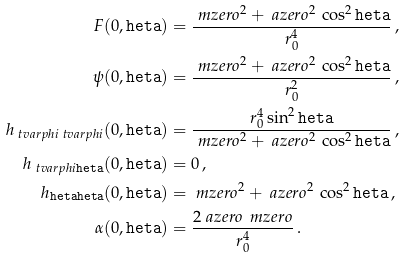<formula> <loc_0><loc_0><loc_500><loc_500>F ( 0 , \tt h e t a ) & = \frac { \ m z e r o ^ { 2 } + \ a z e r o ^ { 2 } \, \cos ^ { 2 } \tt h e t a } { r _ { 0 } ^ { 4 } } \, , \\ \psi ( 0 , \tt h e t a ) & = \frac { \ m z e r o ^ { 2 } + \ a z e r o ^ { 2 } \, \cos ^ { 2 } \tt h e t a } { r _ { 0 } ^ { 2 } } \, , \\ h _ { \ t v a r p h i \ t v a r p h i } ( 0 , \tt h e t a ) & = \frac { r _ { 0 } ^ { 4 } \sin ^ { 2 } \tt h e t a } { \ m z e r o ^ { 2 } + \ a z e r o ^ { 2 } \, \cos ^ { 2 } \tt h e t a } \, , \\ h _ { \ t v a r p h i \tt h e t a } ( 0 , \tt h e t a ) & = 0 \, , \\ h _ { \tt h e t a \tt h e t a } ( 0 , \tt h e t a ) & = \ m z e r o ^ { 2 } + \ a z e r o ^ { 2 } \, \cos ^ { 2 } \tt h e t a \, , \\ \alpha ( 0 , \tt h e t a ) & = \frac { 2 \ a z e r o \, \ m z e r o } { r _ { 0 } ^ { 4 } } \, .</formula> 